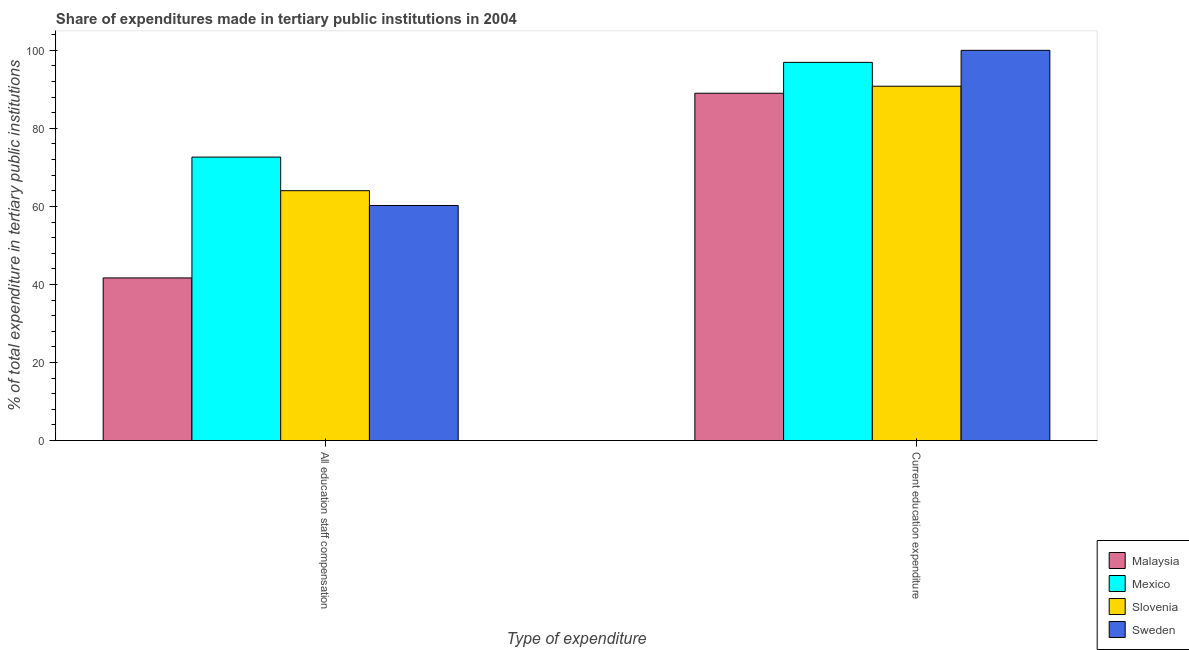How many groups of bars are there?
Provide a succinct answer. 2. Are the number of bars on each tick of the X-axis equal?
Your answer should be very brief. Yes. How many bars are there on the 2nd tick from the left?
Your answer should be compact. 4. How many bars are there on the 1st tick from the right?
Provide a short and direct response. 4. What is the label of the 1st group of bars from the left?
Provide a short and direct response. All education staff compensation. What is the expenditure in staff compensation in Malaysia?
Keep it short and to the point. 41.68. Across all countries, what is the minimum expenditure in staff compensation?
Provide a short and direct response. 41.68. In which country was the expenditure in staff compensation minimum?
Give a very brief answer. Malaysia. What is the total expenditure in staff compensation in the graph?
Your answer should be very brief. 238.6. What is the difference between the expenditure in education in Slovenia and that in Mexico?
Offer a very short reply. -6.12. What is the difference between the expenditure in staff compensation in Malaysia and the expenditure in education in Slovenia?
Make the answer very short. -49.12. What is the average expenditure in education per country?
Keep it short and to the point. 94.18. What is the difference between the expenditure in staff compensation and expenditure in education in Mexico?
Keep it short and to the point. -24.27. What is the ratio of the expenditure in staff compensation in Sweden to that in Malaysia?
Offer a very short reply. 1.45. Is the expenditure in staff compensation in Malaysia less than that in Sweden?
Give a very brief answer. Yes. What does the 3rd bar from the left in All education staff compensation represents?
Give a very brief answer. Slovenia. How many countries are there in the graph?
Your answer should be compact. 4. Where does the legend appear in the graph?
Your answer should be compact. Bottom right. How are the legend labels stacked?
Offer a very short reply. Vertical. What is the title of the graph?
Provide a short and direct response. Share of expenditures made in tertiary public institutions in 2004. What is the label or title of the X-axis?
Your answer should be very brief. Type of expenditure. What is the label or title of the Y-axis?
Your answer should be very brief. % of total expenditure in tertiary public institutions. What is the % of total expenditure in tertiary public institutions in Malaysia in All education staff compensation?
Make the answer very short. 41.68. What is the % of total expenditure in tertiary public institutions in Mexico in All education staff compensation?
Ensure brevity in your answer.  72.65. What is the % of total expenditure in tertiary public institutions of Slovenia in All education staff compensation?
Offer a terse response. 64.03. What is the % of total expenditure in tertiary public institutions in Sweden in All education staff compensation?
Provide a succinct answer. 60.24. What is the % of total expenditure in tertiary public institutions in Malaysia in Current education expenditure?
Provide a short and direct response. 89. What is the % of total expenditure in tertiary public institutions in Mexico in Current education expenditure?
Keep it short and to the point. 96.92. What is the % of total expenditure in tertiary public institutions in Slovenia in Current education expenditure?
Give a very brief answer. 90.8. Across all Type of expenditure, what is the maximum % of total expenditure in tertiary public institutions of Malaysia?
Provide a short and direct response. 89. Across all Type of expenditure, what is the maximum % of total expenditure in tertiary public institutions of Mexico?
Your response must be concise. 96.92. Across all Type of expenditure, what is the maximum % of total expenditure in tertiary public institutions in Slovenia?
Your response must be concise. 90.8. Across all Type of expenditure, what is the maximum % of total expenditure in tertiary public institutions in Sweden?
Provide a succinct answer. 100. Across all Type of expenditure, what is the minimum % of total expenditure in tertiary public institutions of Malaysia?
Offer a terse response. 41.68. Across all Type of expenditure, what is the minimum % of total expenditure in tertiary public institutions of Mexico?
Make the answer very short. 72.65. Across all Type of expenditure, what is the minimum % of total expenditure in tertiary public institutions of Slovenia?
Your response must be concise. 64.03. Across all Type of expenditure, what is the minimum % of total expenditure in tertiary public institutions of Sweden?
Offer a terse response. 60.24. What is the total % of total expenditure in tertiary public institutions in Malaysia in the graph?
Keep it short and to the point. 130.68. What is the total % of total expenditure in tertiary public institutions in Mexico in the graph?
Keep it short and to the point. 169.56. What is the total % of total expenditure in tertiary public institutions in Slovenia in the graph?
Give a very brief answer. 154.83. What is the total % of total expenditure in tertiary public institutions in Sweden in the graph?
Provide a short and direct response. 160.24. What is the difference between the % of total expenditure in tertiary public institutions of Malaysia in All education staff compensation and that in Current education expenditure?
Your answer should be very brief. -47.32. What is the difference between the % of total expenditure in tertiary public institutions in Mexico in All education staff compensation and that in Current education expenditure?
Provide a succinct answer. -24.27. What is the difference between the % of total expenditure in tertiary public institutions in Slovenia in All education staff compensation and that in Current education expenditure?
Give a very brief answer. -26.77. What is the difference between the % of total expenditure in tertiary public institutions in Sweden in All education staff compensation and that in Current education expenditure?
Offer a very short reply. -39.76. What is the difference between the % of total expenditure in tertiary public institutions in Malaysia in All education staff compensation and the % of total expenditure in tertiary public institutions in Mexico in Current education expenditure?
Give a very brief answer. -55.24. What is the difference between the % of total expenditure in tertiary public institutions in Malaysia in All education staff compensation and the % of total expenditure in tertiary public institutions in Slovenia in Current education expenditure?
Your response must be concise. -49.12. What is the difference between the % of total expenditure in tertiary public institutions in Malaysia in All education staff compensation and the % of total expenditure in tertiary public institutions in Sweden in Current education expenditure?
Provide a short and direct response. -58.32. What is the difference between the % of total expenditure in tertiary public institutions of Mexico in All education staff compensation and the % of total expenditure in tertiary public institutions of Slovenia in Current education expenditure?
Your answer should be very brief. -18.16. What is the difference between the % of total expenditure in tertiary public institutions of Mexico in All education staff compensation and the % of total expenditure in tertiary public institutions of Sweden in Current education expenditure?
Make the answer very short. -27.35. What is the difference between the % of total expenditure in tertiary public institutions of Slovenia in All education staff compensation and the % of total expenditure in tertiary public institutions of Sweden in Current education expenditure?
Offer a very short reply. -35.97. What is the average % of total expenditure in tertiary public institutions of Malaysia per Type of expenditure?
Give a very brief answer. 65.34. What is the average % of total expenditure in tertiary public institutions of Mexico per Type of expenditure?
Ensure brevity in your answer.  84.78. What is the average % of total expenditure in tertiary public institutions in Slovenia per Type of expenditure?
Give a very brief answer. 77.42. What is the average % of total expenditure in tertiary public institutions of Sweden per Type of expenditure?
Offer a terse response. 80.12. What is the difference between the % of total expenditure in tertiary public institutions of Malaysia and % of total expenditure in tertiary public institutions of Mexico in All education staff compensation?
Offer a terse response. -30.97. What is the difference between the % of total expenditure in tertiary public institutions in Malaysia and % of total expenditure in tertiary public institutions in Slovenia in All education staff compensation?
Ensure brevity in your answer.  -22.35. What is the difference between the % of total expenditure in tertiary public institutions of Malaysia and % of total expenditure in tertiary public institutions of Sweden in All education staff compensation?
Provide a short and direct response. -18.56. What is the difference between the % of total expenditure in tertiary public institutions in Mexico and % of total expenditure in tertiary public institutions in Slovenia in All education staff compensation?
Keep it short and to the point. 8.62. What is the difference between the % of total expenditure in tertiary public institutions in Mexico and % of total expenditure in tertiary public institutions in Sweden in All education staff compensation?
Provide a succinct answer. 12.4. What is the difference between the % of total expenditure in tertiary public institutions in Slovenia and % of total expenditure in tertiary public institutions in Sweden in All education staff compensation?
Make the answer very short. 3.79. What is the difference between the % of total expenditure in tertiary public institutions in Malaysia and % of total expenditure in tertiary public institutions in Mexico in Current education expenditure?
Make the answer very short. -7.91. What is the difference between the % of total expenditure in tertiary public institutions of Malaysia and % of total expenditure in tertiary public institutions of Slovenia in Current education expenditure?
Your answer should be very brief. -1.8. What is the difference between the % of total expenditure in tertiary public institutions in Malaysia and % of total expenditure in tertiary public institutions in Sweden in Current education expenditure?
Your response must be concise. -11. What is the difference between the % of total expenditure in tertiary public institutions in Mexico and % of total expenditure in tertiary public institutions in Slovenia in Current education expenditure?
Your answer should be compact. 6.12. What is the difference between the % of total expenditure in tertiary public institutions of Mexico and % of total expenditure in tertiary public institutions of Sweden in Current education expenditure?
Provide a short and direct response. -3.08. What is the difference between the % of total expenditure in tertiary public institutions of Slovenia and % of total expenditure in tertiary public institutions of Sweden in Current education expenditure?
Keep it short and to the point. -9.2. What is the ratio of the % of total expenditure in tertiary public institutions of Malaysia in All education staff compensation to that in Current education expenditure?
Your answer should be very brief. 0.47. What is the ratio of the % of total expenditure in tertiary public institutions in Mexico in All education staff compensation to that in Current education expenditure?
Provide a short and direct response. 0.75. What is the ratio of the % of total expenditure in tertiary public institutions in Slovenia in All education staff compensation to that in Current education expenditure?
Make the answer very short. 0.71. What is the ratio of the % of total expenditure in tertiary public institutions in Sweden in All education staff compensation to that in Current education expenditure?
Your response must be concise. 0.6. What is the difference between the highest and the second highest % of total expenditure in tertiary public institutions in Malaysia?
Make the answer very short. 47.32. What is the difference between the highest and the second highest % of total expenditure in tertiary public institutions in Mexico?
Your response must be concise. 24.27. What is the difference between the highest and the second highest % of total expenditure in tertiary public institutions of Slovenia?
Your answer should be compact. 26.77. What is the difference between the highest and the second highest % of total expenditure in tertiary public institutions in Sweden?
Your answer should be very brief. 39.76. What is the difference between the highest and the lowest % of total expenditure in tertiary public institutions of Malaysia?
Your response must be concise. 47.32. What is the difference between the highest and the lowest % of total expenditure in tertiary public institutions in Mexico?
Provide a succinct answer. 24.27. What is the difference between the highest and the lowest % of total expenditure in tertiary public institutions of Slovenia?
Provide a short and direct response. 26.77. What is the difference between the highest and the lowest % of total expenditure in tertiary public institutions in Sweden?
Your answer should be compact. 39.76. 